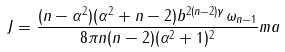<formula> <loc_0><loc_0><loc_500><loc_500>J = \frac { ( n - \alpha ^ { 2 } ) ( \alpha ^ { 2 } + n - 2 ) b ^ { 2 ( n - 2 ) \gamma } \omega _ { n - 1 } } { 8 \pi n ( n - 2 ) ( \alpha ^ { 2 } + 1 ) ^ { 2 } } m a</formula> 